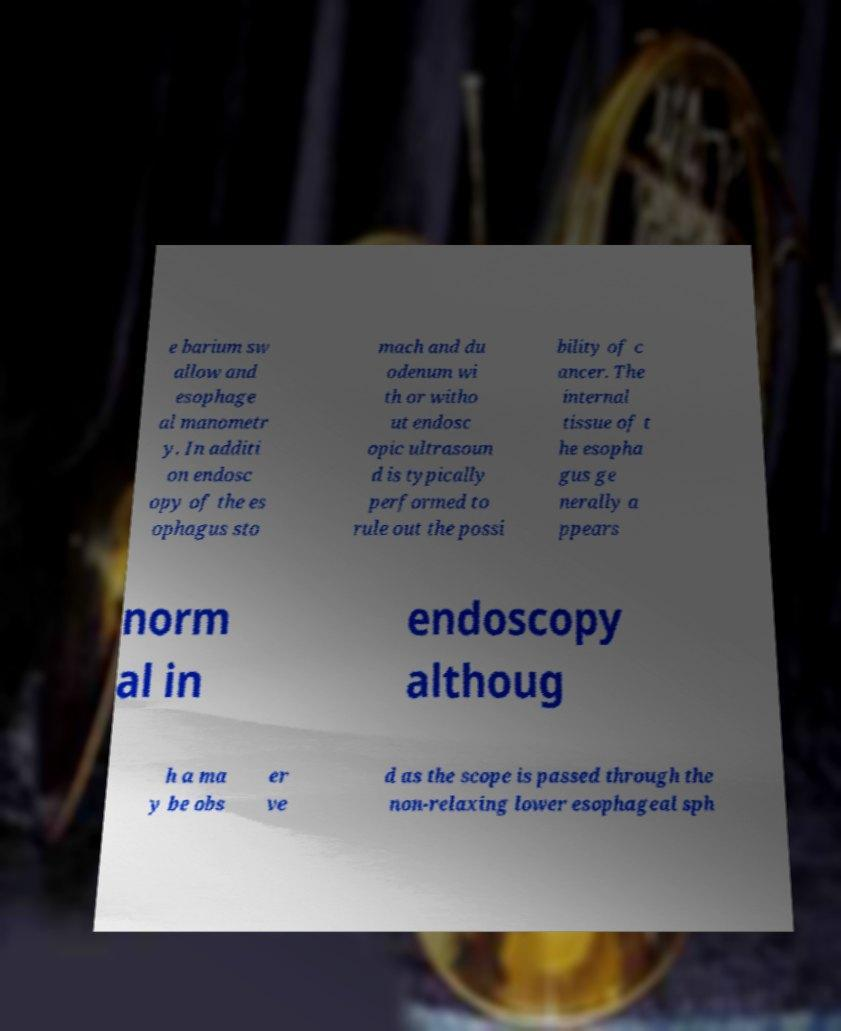Can you read and provide the text displayed in the image?This photo seems to have some interesting text. Can you extract and type it out for me? e barium sw allow and esophage al manometr y. In additi on endosc opy of the es ophagus sto mach and du odenum wi th or witho ut endosc opic ultrasoun d is typically performed to rule out the possi bility of c ancer. The internal tissue of t he esopha gus ge nerally a ppears norm al in endoscopy althoug h a ma y be obs er ve d as the scope is passed through the non-relaxing lower esophageal sph 